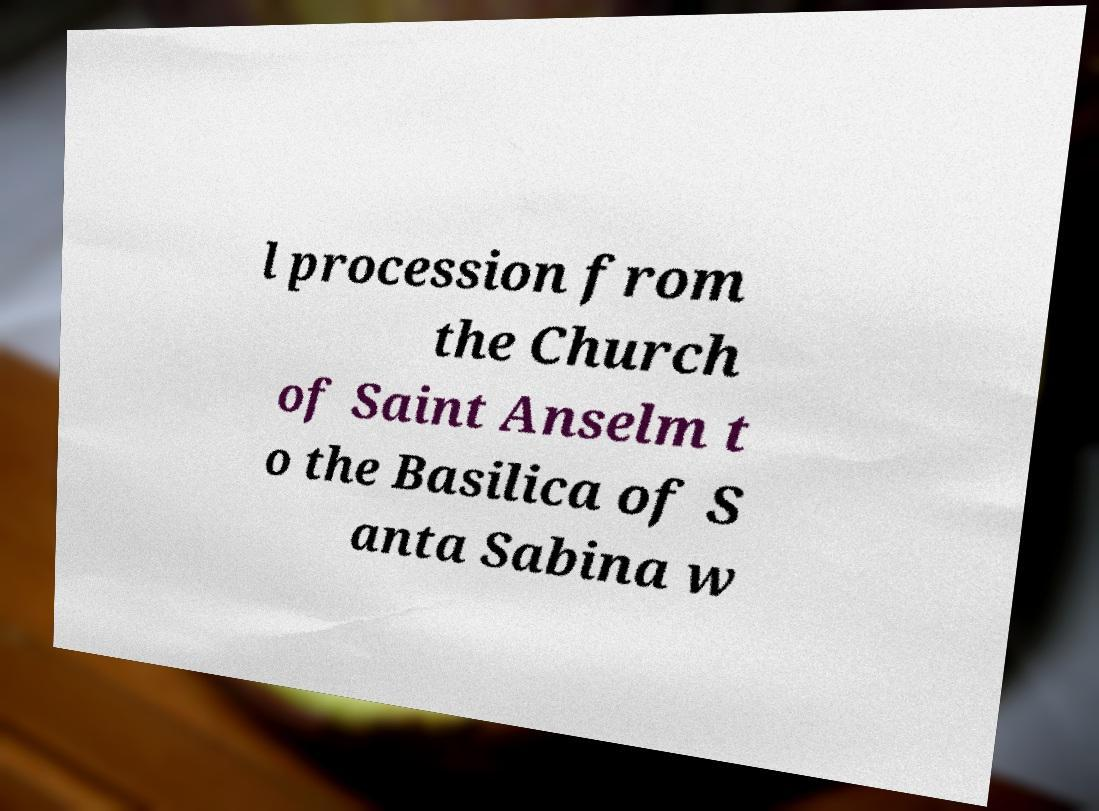Please read and relay the text visible in this image. What does it say? l procession from the Church of Saint Anselm t o the Basilica of S anta Sabina w 